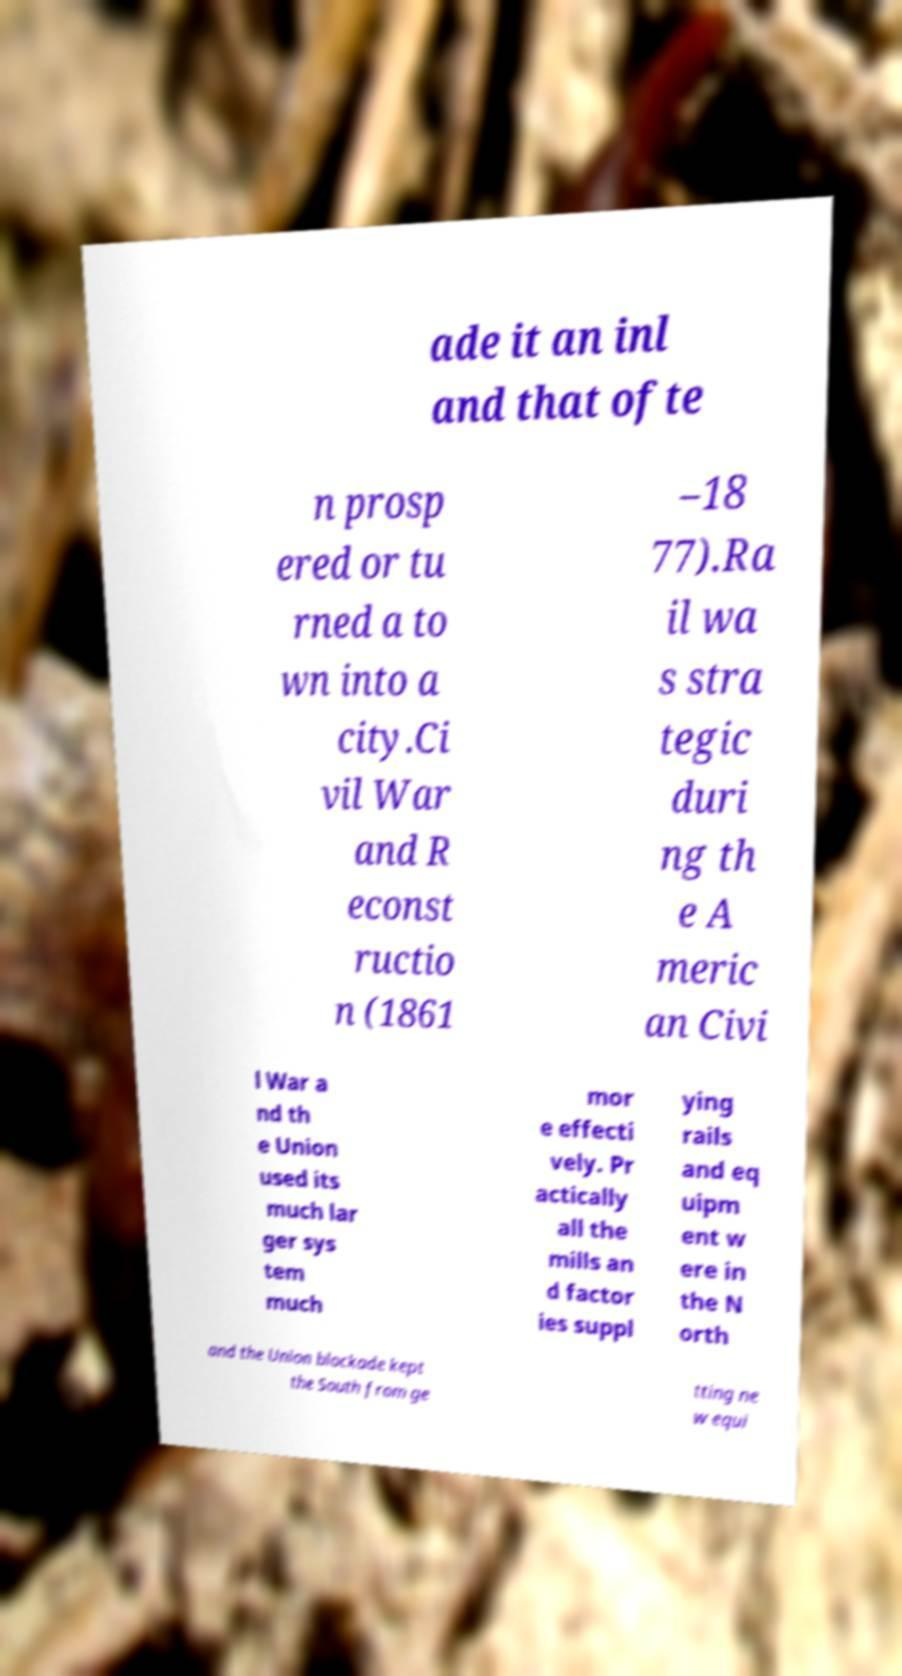Please read and relay the text visible in this image. What does it say? ade it an inl and that ofte n prosp ered or tu rned a to wn into a city.Ci vil War and R econst ructio n (1861 –18 77).Ra il wa s stra tegic duri ng th e A meric an Civi l War a nd th e Union used its much lar ger sys tem much mor e effecti vely. Pr actically all the mills an d factor ies suppl ying rails and eq uipm ent w ere in the N orth and the Union blockade kept the South from ge tting ne w equi 